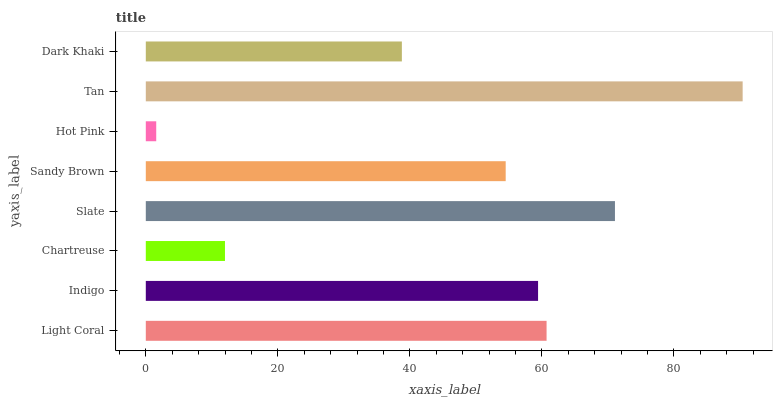Is Hot Pink the minimum?
Answer yes or no. Yes. Is Tan the maximum?
Answer yes or no. Yes. Is Indigo the minimum?
Answer yes or no. No. Is Indigo the maximum?
Answer yes or no. No. Is Light Coral greater than Indigo?
Answer yes or no. Yes. Is Indigo less than Light Coral?
Answer yes or no. Yes. Is Indigo greater than Light Coral?
Answer yes or no. No. Is Light Coral less than Indigo?
Answer yes or no. No. Is Indigo the high median?
Answer yes or no. Yes. Is Sandy Brown the low median?
Answer yes or no. Yes. Is Hot Pink the high median?
Answer yes or no. No. Is Dark Khaki the low median?
Answer yes or no. No. 